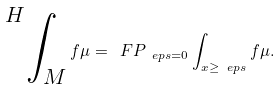Convert formula to latex. <formula><loc_0><loc_0><loc_500><loc_500>\sideset { ^ { H } } { _ { M } } \int f \mu = \ F P _ { \ e p s = 0 } \int _ { x \geq \ e p s } f \mu .</formula> 